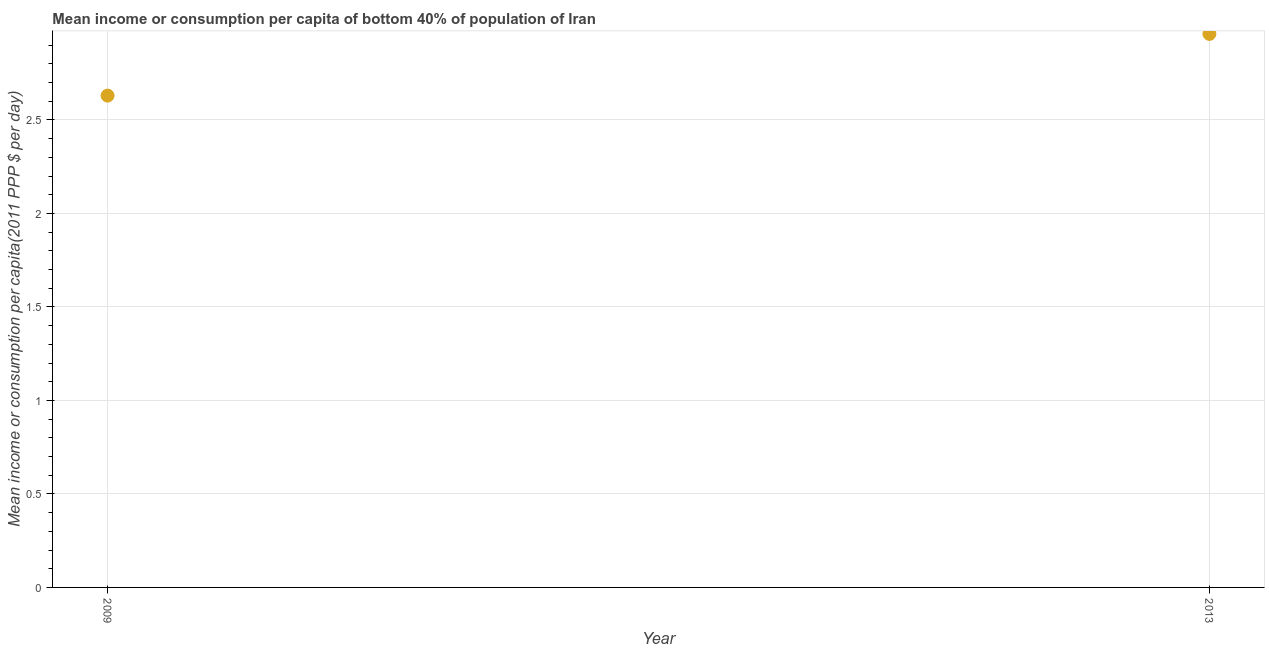What is the mean income or consumption in 2013?
Your answer should be very brief. 2.96. Across all years, what is the maximum mean income or consumption?
Your response must be concise. 2.96. Across all years, what is the minimum mean income or consumption?
Give a very brief answer. 2.63. In which year was the mean income or consumption maximum?
Provide a succinct answer. 2013. In which year was the mean income or consumption minimum?
Your response must be concise. 2009. What is the sum of the mean income or consumption?
Your answer should be compact. 5.59. What is the difference between the mean income or consumption in 2009 and 2013?
Your answer should be very brief. -0.33. What is the average mean income or consumption per year?
Your response must be concise. 2.79. What is the median mean income or consumption?
Provide a short and direct response. 2.79. In how many years, is the mean income or consumption greater than 0.6 $?
Provide a short and direct response. 2. What is the ratio of the mean income or consumption in 2009 to that in 2013?
Give a very brief answer. 0.89. Is the mean income or consumption in 2009 less than that in 2013?
Your answer should be very brief. Yes. What is the difference between two consecutive major ticks on the Y-axis?
Offer a terse response. 0.5. Are the values on the major ticks of Y-axis written in scientific E-notation?
Your response must be concise. No. Does the graph contain grids?
Provide a succinct answer. Yes. What is the title of the graph?
Offer a very short reply. Mean income or consumption per capita of bottom 40% of population of Iran. What is the label or title of the Y-axis?
Offer a terse response. Mean income or consumption per capita(2011 PPP $ per day). What is the Mean income or consumption per capita(2011 PPP $ per day) in 2009?
Make the answer very short. 2.63. What is the Mean income or consumption per capita(2011 PPP $ per day) in 2013?
Your answer should be very brief. 2.96. What is the difference between the Mean income or consumption per capita(2011 PPP $ per day) in 2009 and 2013?
Your answer should be compact. -0.33. What is the ratio of the Mean income or consumption per capita(2011 PPP $ per day) in 2009 to that in 2013?
Offer a terse response. 0.89. 